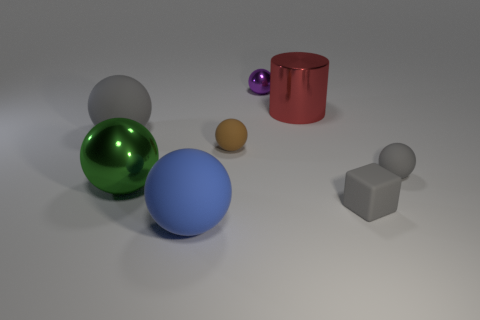How many big matte spheres are the same color as the small cube?
Give a very brief answer. 1. How many rubber objects are in front of the large green thing and behind the big blue thing?
Give a very brief answer. 1. There is a red metallic thing that is the same size as the blue matte thing; what shape is it?
Ensure brevity in your answer.  Cylinder. What is the size of the red object?
Provide a succinct answer. Large. The gray thing in front of the tiny ball to the right of the small ball behind the red cylinder is made of what material?
Give a very brief answer. Rubber. What is the color of the small sphere that is made of the same material as the brown object?
Provide a short and direct response. Gray. How many small gray spheres are on the left side of the tiny gray sphere on the right side of the metal sphere that is in front of the large red metal object?
Provide a succinct answer. 0. What material is the big thing that is the same color as the small matte block?
Your response must be concise. Rubber. Is there any other thing that is the same shape as the small purple shiny thing?
Give a very brief answer. Yes. What number of things are either balls behind the green sphere or blue objects?
Offer a terse response. 5. 